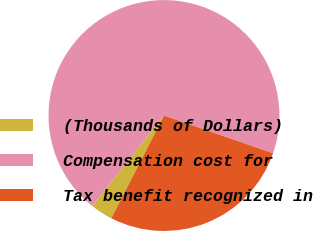Convert chart to OTSL. <chart><loc_0><loc_0><loc_500><loc_500><pie_chart><fcel>(Thousands of Dollars)<fcel>Compensation cost for<fcel>Tax benefit recognized in<nl><fcel>3.12%<fcel>69.64%<fcel>27.23%<nl></chart> 